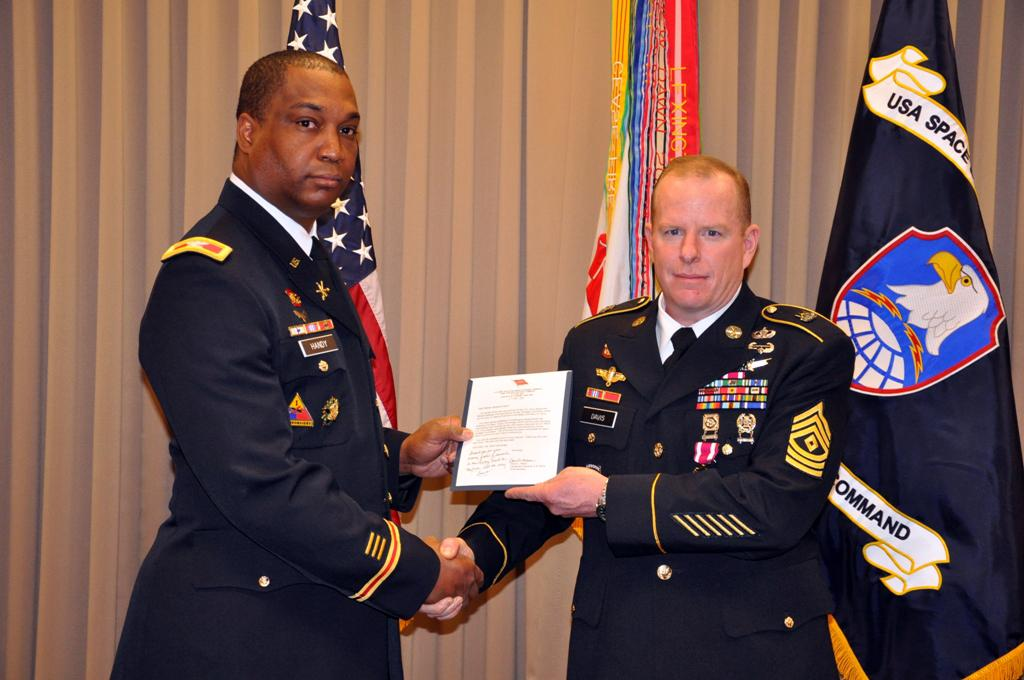Provide a one-sentence caption for the provided image. Two men holding a piece of paper, the words USA space are visible in the background. 